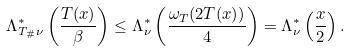Convert formula to latex. <formula><loc_0><loc_0><loc_500><loc_500>\Lambda ^ { * } _ { T _ { \# } \nu } \left ( \frac { T ( x ) } { \beta } \right ) \leq \Lambda ^ { * } _ { \nu } \left ( \frac { \omega _ { T } ( 2 T ( x ) ) } { 4 } \right ) = \Lambda ^ { * } _ { \nu } \left ( \frac { x } { 2 } \right ) .</formula> 